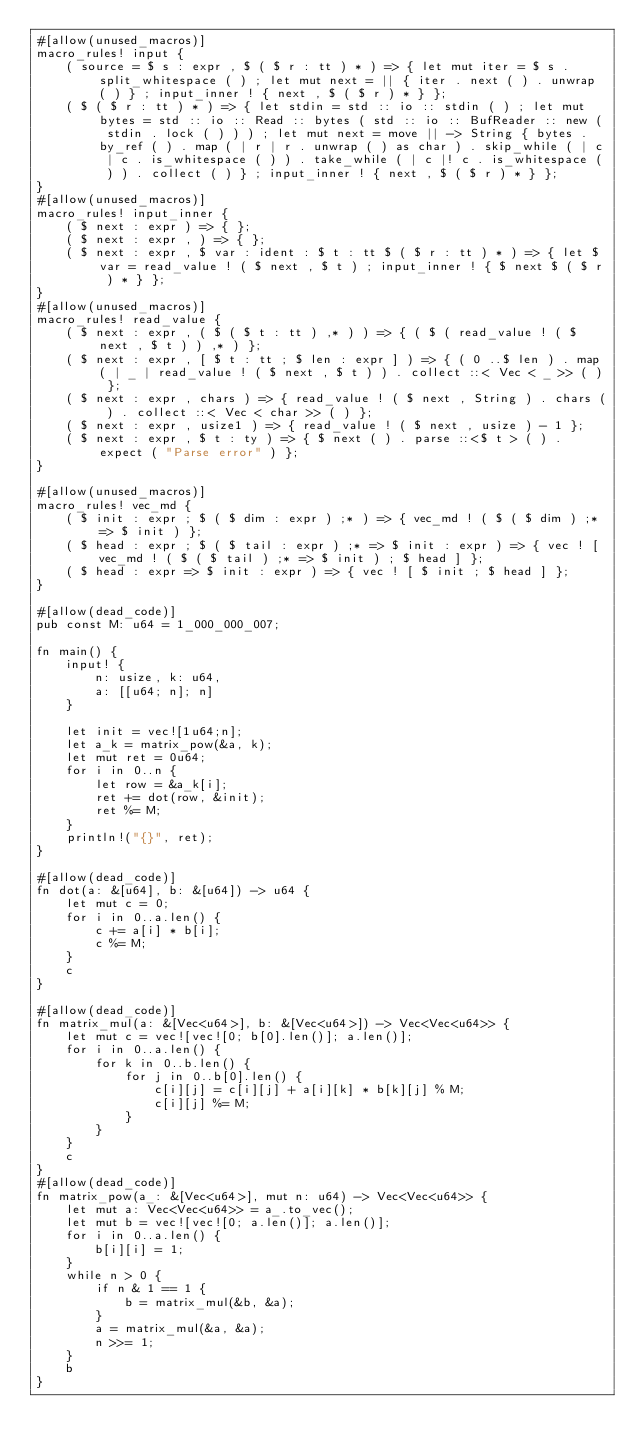Convert code to text. <code><loc_0><loc_0><loc_500><loc_500><_Rust_>#[allow(unused_macros)]
macro_rules! input {
    ( source = $ s : expr , $ ( $ r : tt ) * ) => { let mut iter = $ s . split_whitespace ( ) ; let mut next = || { iter . next ( ) . unwrap ( ) } ; input_inner ! { next , $ ( $ r ) * } };
    ( $ ( $ r : tt ) * ) => { let stdin = std :: io :: stdin ( ) ; let mut bytes = std :: io :: Read :: bytes ( std :: io :: BufReader :: new ( stdin . lock ( ) ) ) ; let mut next = move || -> String { bytes . by_ref ( ) . map ( | r | r . unwrap ( ) as char ) . skip_while ( | c | c . is_whitespace ( ) ) . take_while ( | c |! c . is_whitespace ( ) ) . collect ( ) } ; input_inner ! { next , $ ( $ r ) * } };
}
#[allow(unused_macros)]
macro_rules! input_inner {
    ( $ next : expr ) => { };
    ( $ next : expr , ) => { };
    ( $ next : expr , $ var : ident : $ t : tt $ ( $ r : tt ) * ) => { let $ var = read_value ! ( $ next , $ t ) ; input_inner ! { $ next $ ( $ r ) * } };
}
#[allow(unused_macros)]
macro_rules! read_value {
    ( $ next : expr , ( $ ( $ t : tt ) ,* ) ) => { ( $ ( read_value ! ( $ next , $ t ) ) ,* ) };
    ( $ next : expr , [ $ t : tt ; $ len : expr ] ) => { ( 0 ..$ len ) . map ( | _ | read_value ! ( $ next , $ t ) ) . collect ::< Vec < _ >> ( ) };
    ( $ next : expr , chars ) => { read_value ! ( $ next , String ) . chars ( ) . collect ::< Vec < char >> ( ) };
    ( $ next : expr , usize1 ) => { read_value ! ( $ next , usize ) - 1 };
    ( $ next : expr , $ t : ty ) => { $ next ( ) . parse ::<$ t > ( ) . expect ( "Parse error" ) };
}

#[allow(unused_macros)]
macro_rules! vec_md {
    ( $ init : expr ; $ ( $ dim : expr ) ;* ) => { vec_md ! ( $ ( $ dim ) ;* => $ init ) };
    ( $ head : expr ; $ ( $ tail : expr ) ;* => $ init : expr ) => { vec ! [ vec_md ! ( $ ( $ tail ) ;* => $ init ) ; $ head ] };
    ( $ head : expr => $ init : expr ) => { vec ! [ $ init ; $ head ] };
}

#[allow(dead_code)]
pub const M: u64 = 1_000_000_007;

fn main() {
    input! {
        n: usize, k: u64,
        a: [[u64; n]; n]
    }

    let init = vec![1u64;n];
    let a_k = matrix_pow(&a, k);
    let mut ret = 0u64;
    for i in 0..n {
        let row = &a_k[i];
        ret += dot(row, &init);
        ret %= M;
    }
    println!("{}", ret);
}

#[allow(dead_code)]
fn dot(a: &[u64], b: &[u64]) -> u64 {
    let mut c = 0;
    for i in 0..a.len() {
        c += a[i] * b[i];
        c %= M;
    }
    c
}

#[allow(dead_code)]
fn matrix_mul(a: &[Vec<u64>], b: &[Vec<u64>]) -> Vec<Vec<u64>> {
    let mut c = vec![vec![0; b[0].len()]; a.len()];
    for i in 0..a.len() {
        for k in 0..b.len() {
            for j in 0..b[0].len() {
                c[i][j] = c[i][j] + a[i][k] * b[k][j] % M;
                c[i][j] %= M;
            }
        }
    }
    c
}
#[allow(dead_code)]
fn matrix_pow(a_: &[Vec<u64>], mut n: u64) -> Vec<Vec<u64>> {
    let mut a: Vec<Vec<u64>> = a_.to_vec();
    let mut b = vec![vec![0; a.len()]; a.len()];
    for i in 0..a.len() {
        b[i][i] = 1;
    }
    while n > 0 {
        if n & 1 == 1 {
            b = matrix_mul(&b, &a);
        }
        a = matrix_mul(&a, &a);
        n >>= 1;
    }
    b
}</code> 